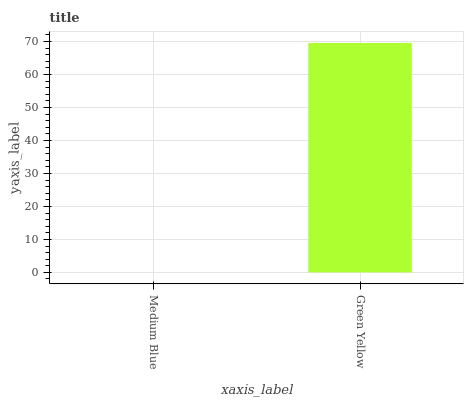Is Medium Blue the minimum?
Answer yes or no. Yes. Is Green Yellow the maximum?
Answer yes or no. Yes. Is Green Yellow the minimum?
Answer yes or no. No. Is Green Yellow greater than Medium Blue?
Answer yes or no. Yes. Is Medium Blue less than Green Yellow?
Answer yes or no. Yes. Is Medium Blue greater than Green Yellow?
Answer yes or no. No. Is Green Yellow less than Medium Blue?
Answer yes or no. No. Is Green Yellow the high median?
Answer yes or no. Yes. Is Medium Blue the low median?
Answer yes or no. Yes. Is Medium Blue the high median?
Answer yes or no. No. Is Green Yellow the low median?
Answer yes or no. No. 